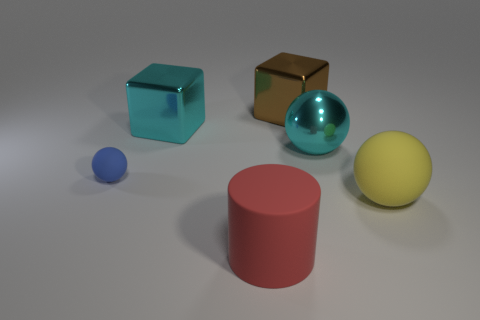How many large objects are both on the right side of the brown thing and behind the blue object?
Offer a very short reply. 1. What is the size of the matte thing that is to the left of the large object in front of the large yellow ball?
Your answer should be compact. Small. Is the number of matte objects left of the yellow object less than the number of things that are in front of the large brown shiny object?
Your answer should be compact. Yes. Is the color of the big metal thing on the left side of the large brown metallic cube the same as the shiny object on the right side of the brown block?
Provide a short and direct response. Yes. What is the material of the ball that is both behind the yellow rubber ball and on the right side of the blue rubber object?
Your response must be concise. Metal. Are there any large brown rubber things?
Provide a short and direct response. No. There is a large brown object that is made of the same material as the cyan ball; what shape is it?
Offer a very short reply. Cube. Do the small rubber thing and the yellow thing that is in front of the cyan metallic ball have the same shape?
Your answer should be very brief. Yes. What is the material of the cyan thing that is left of the cyan object in front of the big cyan metallic cube?
Your answer should be compact. Metal. What number of other things are there of the same shape as the red rubber thing?
Your response must be concise. 0. 